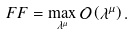<formula> <loc_0><loc_0><loc_500><loc_500>F F = \max _ { \lambda ^ { \mu } } { \mathcal { O } } \left ( \lambda ^ { \mu } \right ) .</formula> 